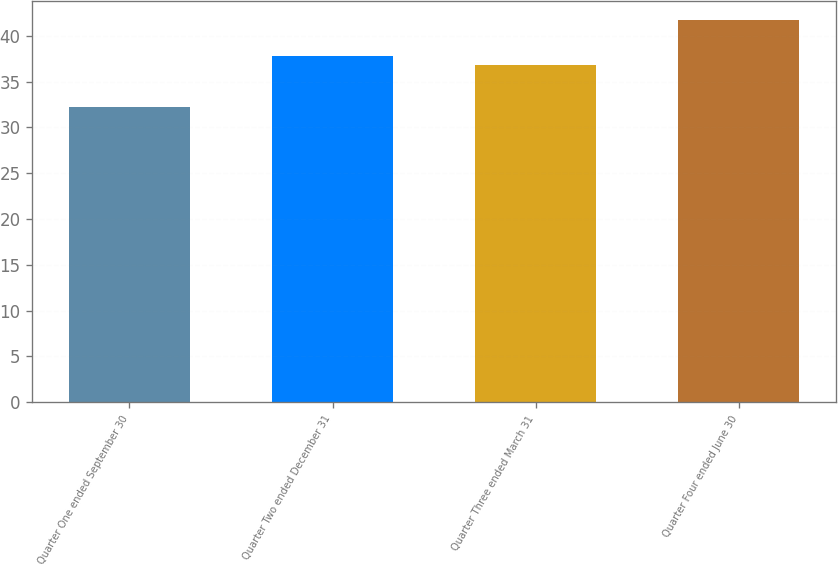Convert chart to OTSL. <chart><loc_0><loc_0><loc_500><loc_500><bar_chart><fcel>Quarter One ended September 30<fcel>Quarter Two ended December 31<fcel>Quarter Three ended March 31<fcel>Quarter Four ended June 30<nl><fcel>32.21<fcel>37.81<fcel>36.86<fcel>41.76<nl></chart> 